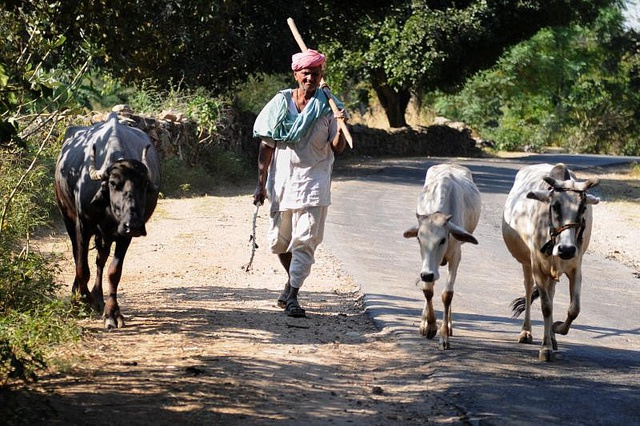Describe the objects in this image and their specific colors. I can see cow in black, gray, darkgray, and lightgray tones, people in black, gray, white, and darkgray tones, cow in black, gray, lightgray, and darkgray tones, and cow in black, gray, darkgray, and lightgray tones in this image. 